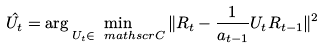Convert formula to latex. <formula><loc_0><loc_0><loc_500><loc_500>\hat { U _ { t } } = \arg \min _ { U _ { t } \in \ m a t h s c r { C } } \| R _ { t } - \frac { 1 } { a _ { t - 1 } } U _ { t } R _ { t - 1 } \| ^ { 2 }</formula> 